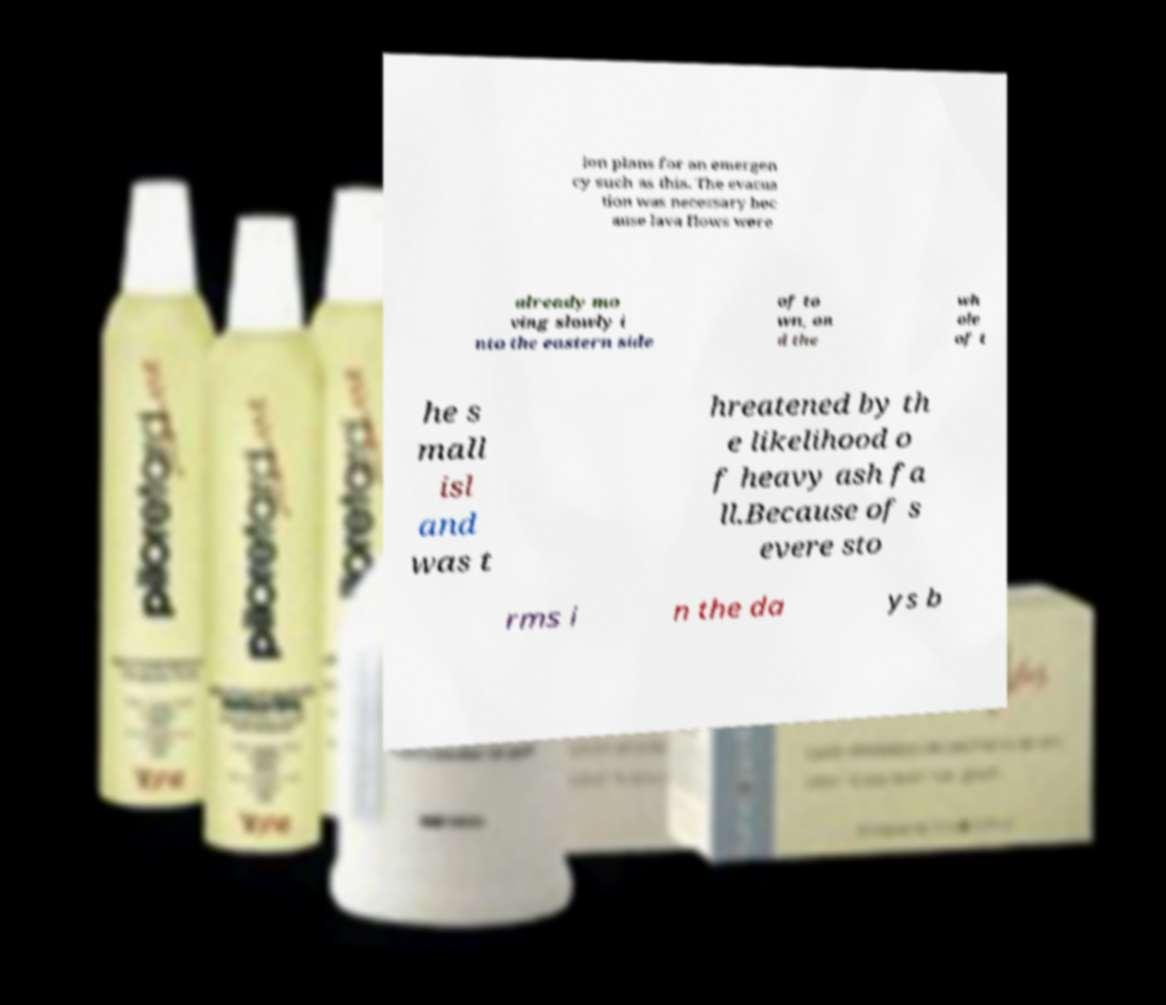Can you read and provide the text displayed in the image?This photo seems to have some interesting text. Can you extract and type it out for me? ion plans for an emergen cy such as this. The evacua tion was necessary bec ause lava flows were already mo ving slowly i nto the eastern side of to wn, an d the wh ole of t he s mall isl and was t hreatened by th e likelihood o f heavy ash fa ll.Because of s evere sto rms i n the da ys b 